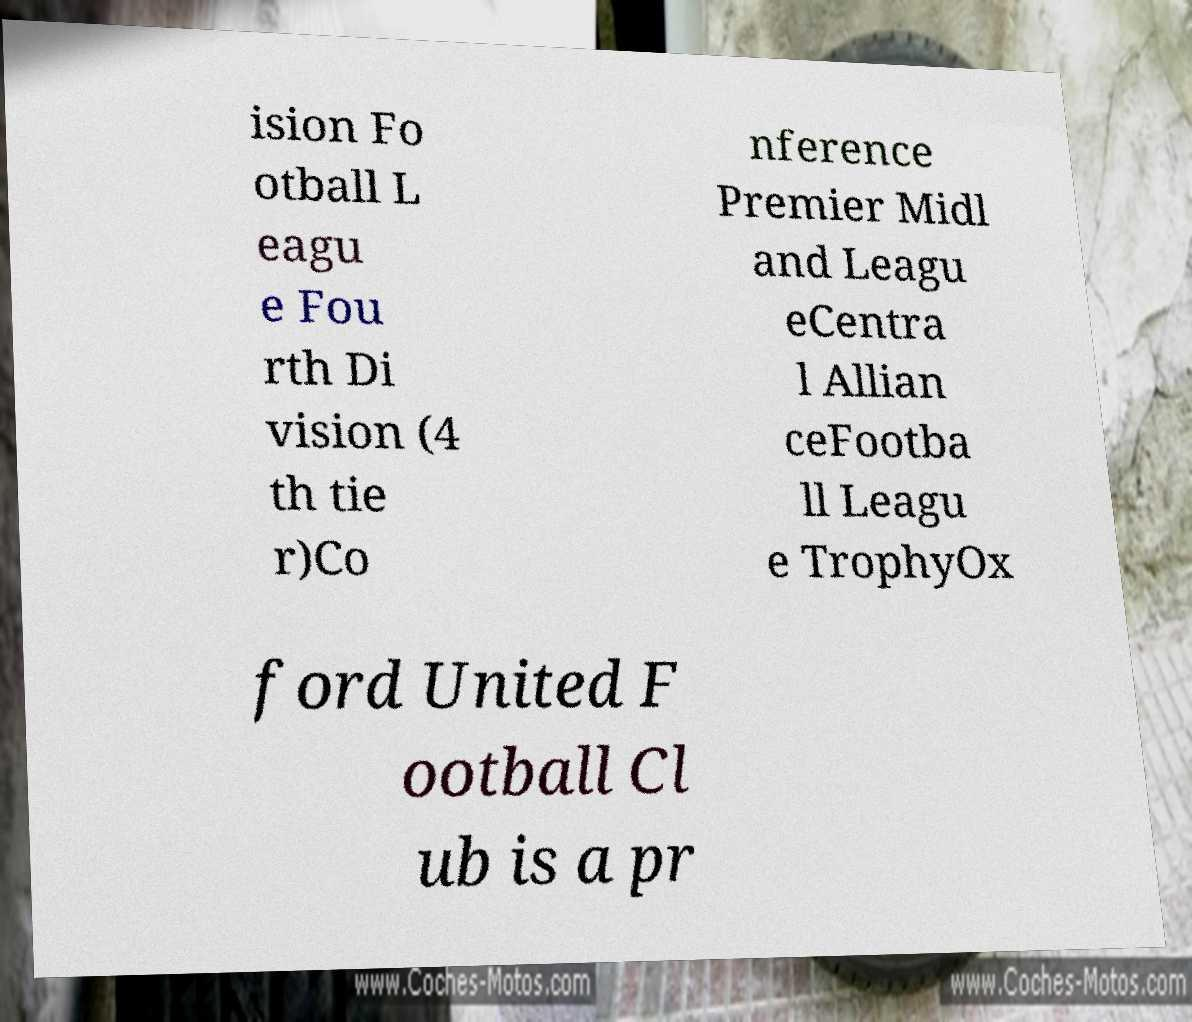Please read and relay the text visible in this image. What does it say? ision Fo otball L eagu e Fou rth Di vision (4 th tie r)Co nference Premier Midl and Leagu eCentra l Allian ceFootba ll Leagu e TrophyOx ford United F ootball Cl ub is a pr 